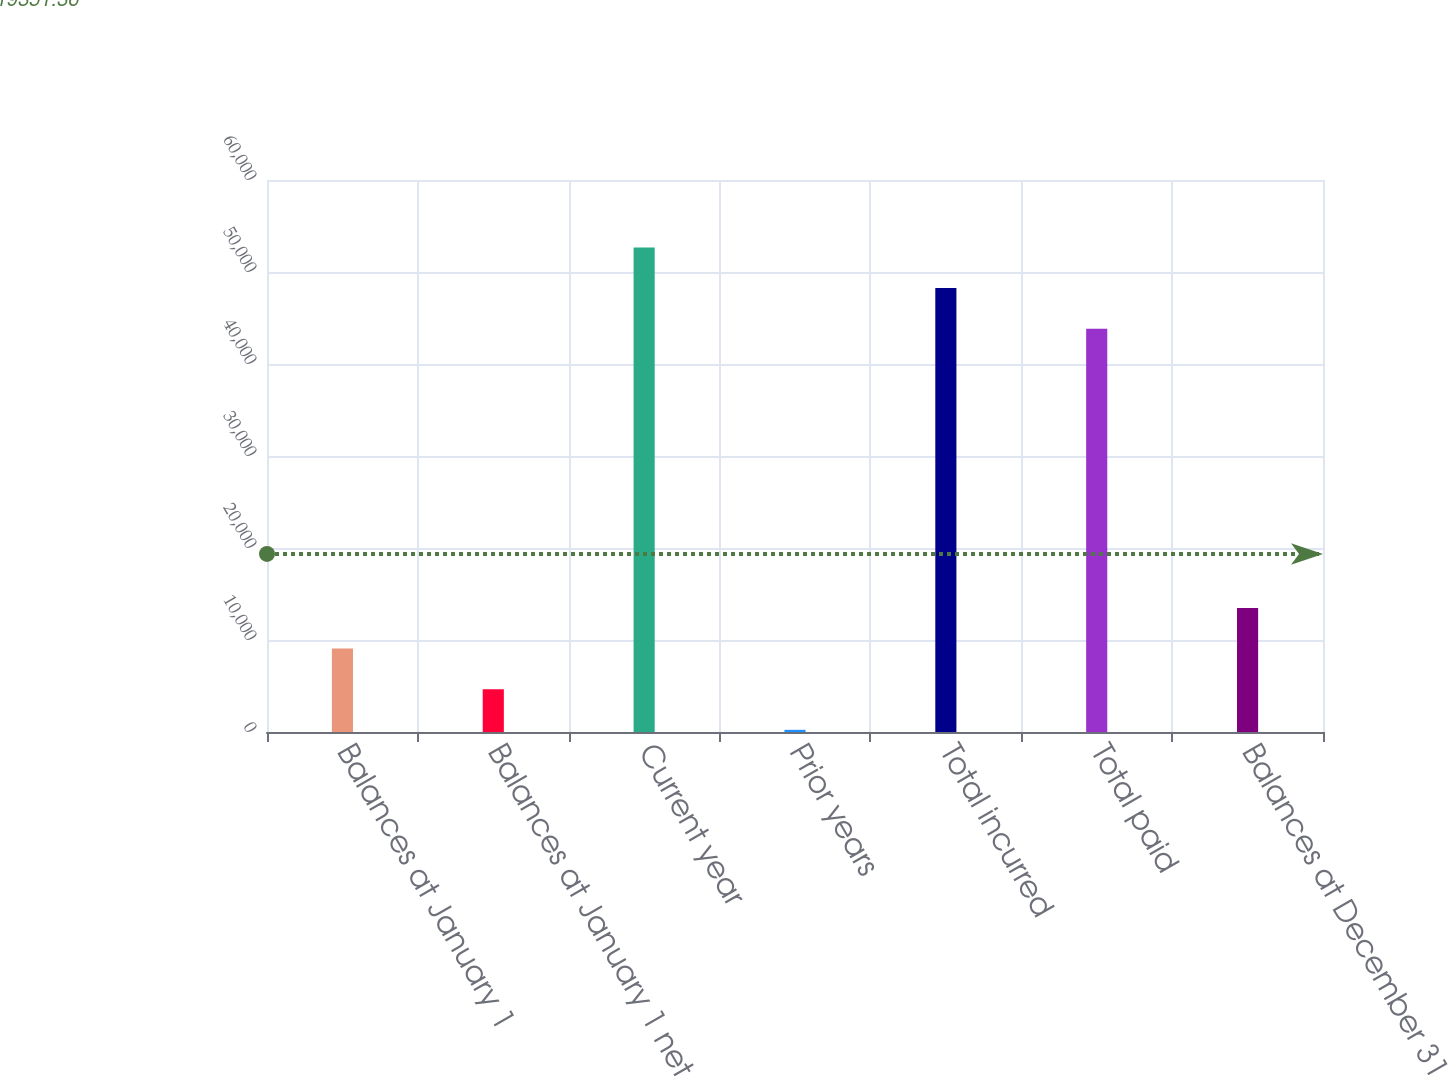Convert chart to OTSL. <chart><loc_0><loc_0><loc_500><loc_500><bar_chart><fcel>Balances at January 1<fcel>Balances at January 1 net<fcel>Current year<fcel>Prior years<fcel>Total incurred<fcel>Total paid<fcel>Balances at December 31<nl><fcel>9068.2<fcel>4652.1<fcel>52675.2<fcel>236<fcel>48259.1<fcel>43843<fcel>13484.3<nl></chart> 